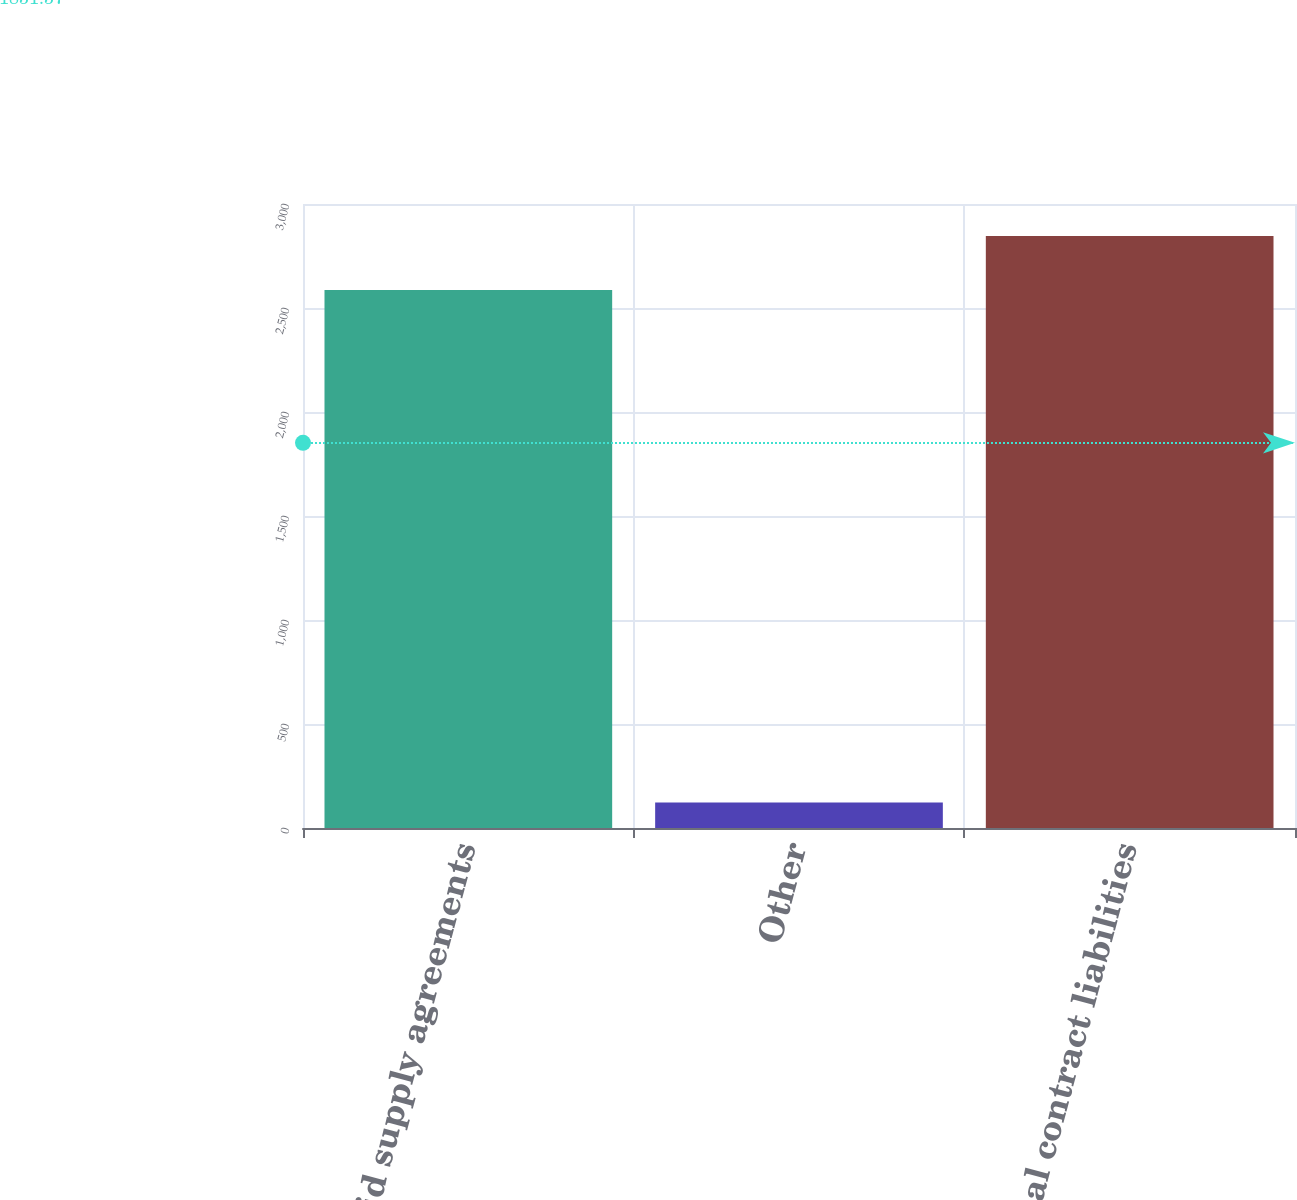<chart> <loc_0><loc_0><loc_500><loc_500><bar_chart><fcel>Prepaid supply agreements<fcel>Other<fcel>Total contract liabilities<nl><fcel>2587<fcel>122<fcel>2845.7<nl></chart> 